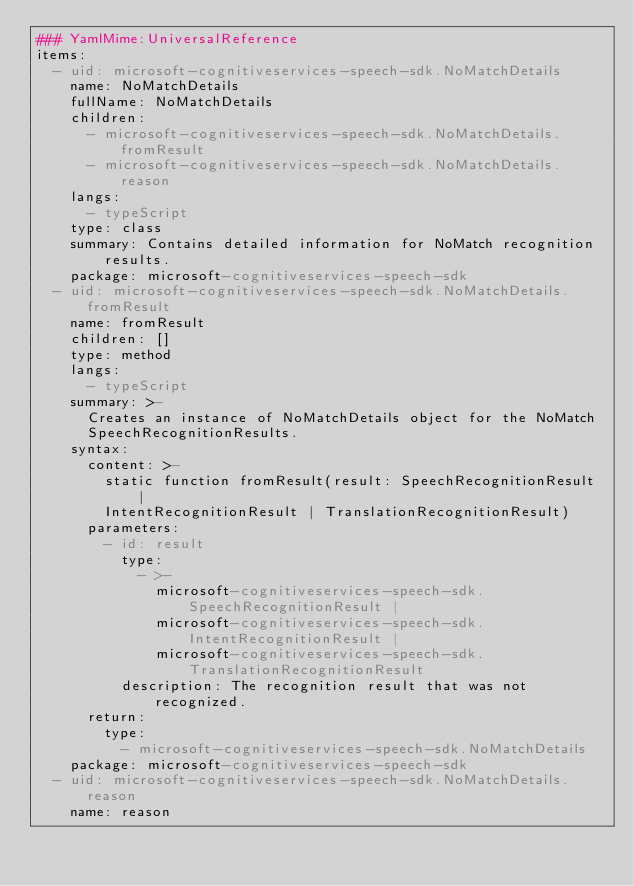Convert code to text. <code><loc_0><loc_0><loc_500><loc_500><_YAML_>### YamlMime:UniversalReference
items:
  - uid: microsoft-cognitiveservices-speech-sdk.NoMatchDetails
    name: NoMatchDetails
    fullName: NoMatchDetails
    children:
      - microsoft-cognitiveservices-speech-sdk.NoMatchDetails.fromResult
      - microsoft-cognitiveservices-speech-sdk.NoMatchDetails.reason
    langs:
      - typeScript
    type: class
    summary: Contains detailed information for NoMatch recognition results.
    package: microsoft-cognitiveservices-speech-sdk
  - uid: microsoft-cognitiveservices-speech-sdk.NoMatchDetails.fromResult
    name: fromResult
    children: []
    type: method
    langs:
      - typeScript
    summary: >-
      Creates an instance of NoMatchDetails object for the NoMatch
      SpeechRecognitionResults.
    syntax:
      content: >-
        static function fromResult(result: SpeechRecognitionResult |
        IntentRecognitionResult | TranslationRecognitionResult)
      parameters:
        - id: result
          type:
            - >-
              microsoft-cognitiveservices-speech-sdk.SpeechRecognitionResult |
              microsoft-cognitiveservices-speech-sdk.IntentRecognitionResult |
              microsoft-cognitiveservices-speech-sdk.TranslationRecognitionResult
          description: The recognition result that was not recognized.
      return:
        type:
          - microsoft-cognitiveservices-speech-sdk.NoMatchDetails
    package: microsoft-cognitiveservices-speech-sdk
  - uid: microsoft-cognitiveservices-speech-sdk.NoMatchDetails.reason
    name: reason</code> 